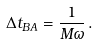<formula> <loc_0><loc_0><loc_500><loc_500>\Delta t _ { B A } = \frac { 1 } { M \omega } \, .</formula> 